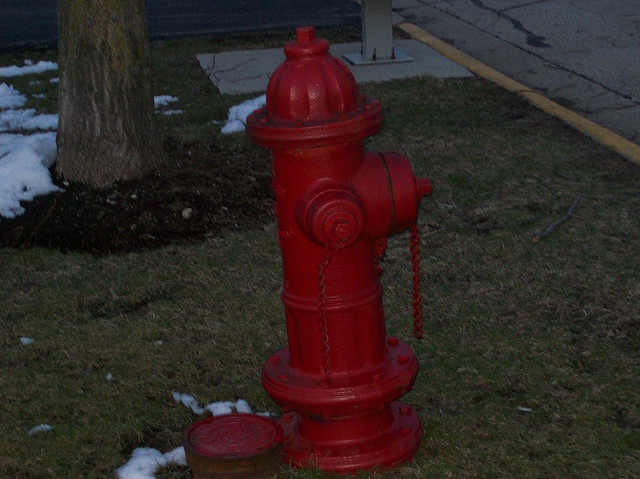Describe the objects in this image and their specific colors. I can see a fire hydrant in black, maroon, and brown tones in this image. 